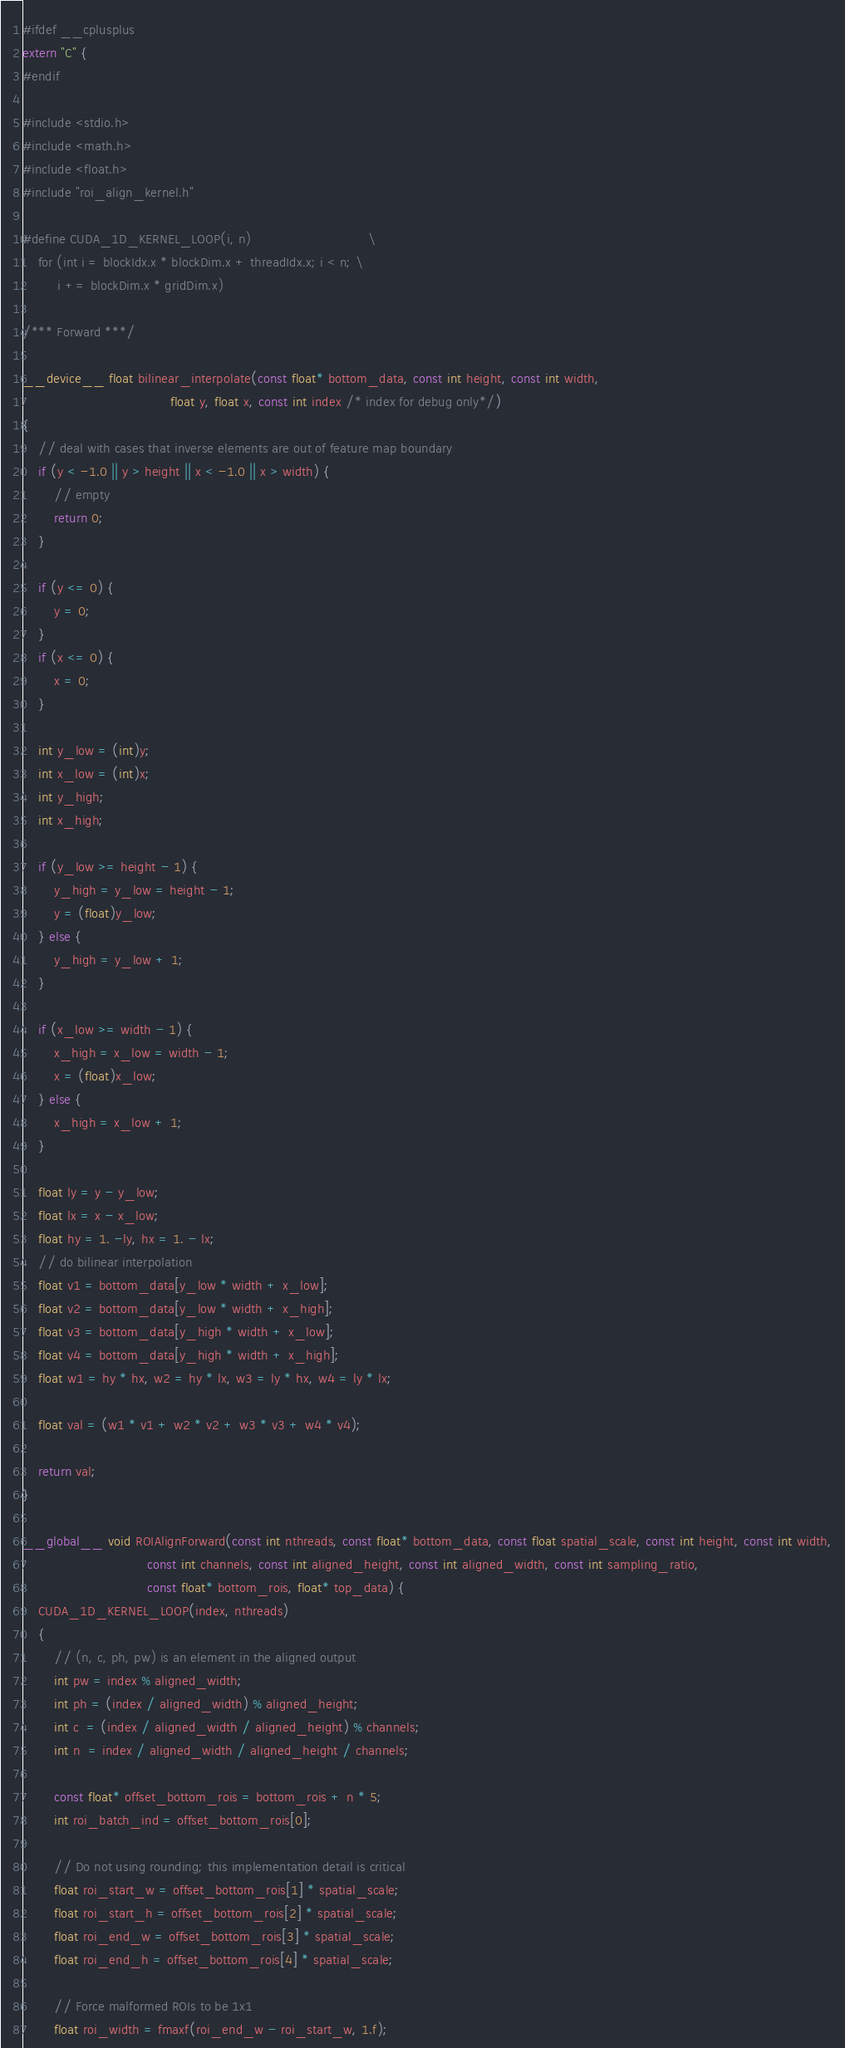<code> <loc_0><loc_0><loc_500><loc_500><_Cuda_>#ifdef __cplusplus
extern "C" {
#endif

#include <stdio.h>
#include <math.h>
#include <float.h>
#include "roi_align_kernel.h"

#define CUDA_1D_KERNEL_LOOP(i, n)                              \
    for (int i = blockIdx.x * blockDim.x + threadIdx.x; i < n; \
         i += blockDim.x * gridDim.x)

/*** Forward ***/

__device__ float bilinear_interpolate(const float* bottom_data, const int height, const int width,
                                      float y, float x, const int index /* index for debug only*/) 
{
    // deal with cases that inverse elements are out of feature map boundary
    if (y < -1.0 || y > height || x < -1.0 || x > width) {
        // empty
        return 0;
    }

    if (y <= 0) {
        y = 0;
    }
    if (x <= 0) {
        x = 0;
    }
    
    int y_low = (int)y;
    int x_low = (int)x;
    int y_high;
    int x_high;
    
    if (y_low >= height - 1) {
        y_high = y_low = height - 1;
        y = (float)y_low;
    } else {
        y_high = y_low + 1;
    }
    
    if (x_low >= width - 1) {
        x_high = x_low = width - 1;
        x = (float)x_low;
    } else {
        x_high = x_low + 1;
    }
    
    float ly = y - y_low;
    float lx = x - x_low;
    float hy = 1. -ly, hx = 1. - lx;
    // do bilinear interpolation
    float v1 = bottom_data[y_low * width + x_low];
    float v2 = bottom_data[y_low * width + x_high];
    float v3 = bottom_data[y_high * width + x_low];
    float v4 = bottom_data[y_high * width + x_high];
    float w1 = hy * hx, w2 = hy * lx, w3 = ly * hx, w4 = ly * lx;

    float val = (w1 * v1 + w2 * v2 + w3 * v3 + w4 * v4);

    return val;
}

__global__ void ROIAlignForward(const int nthreads, const float* bottom_data, const float spatial_scale, const int height, const int width,
                                const int channels, const int aligned_height, const int aligned_width, const int sampling_ratio,
                                const float* bottom_rois, float* top_data) {
    CUDA_1D_KERNEL_LOOP(index, nthreads) 
    {
        // (n, c, ph, pw) is an element in the aligned output
        int pw = index % aligned_width;
        int ph = (index / aligned_width) % aligned_height;
        int c  = (index / aligned_width / aligned_height) % channels;
        int n  = index / aligned_width / aligned_height / channels;

        const float* offset_bottom_rois = bottom_rois + n * 5;
        int roi_batch_ind = offset_bottom_rois[0];

        // Do not using rounding; this implementation detail is critical
        float roi_start_w = offset_bottom_rois[1] * spatial_scale;
        float roi_start_h = offset_bottom_rois[2] * spatial_scale;
        float roi_end_w = offset_bottom_rois[3] * spatial_scale;
        float roi_end_h = offset_bottom_rois[4] * spatial_scale;

        // Force malformed ROIs to be 1x1
        float roi_width = fmaxf(roi_end_w - roi_start_w, 1.f);</code> 